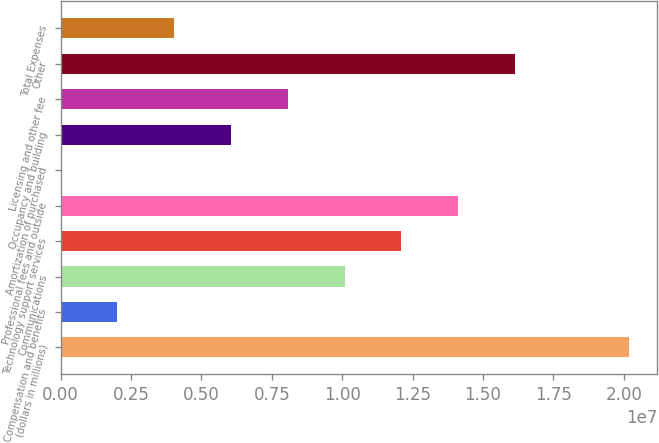Convert chart. <chart><loc_0><loc_0><loc_500><loc_500><bar_chart><fcel>(dollars in millions)<fcel>Compensation and benefits<fcel>Communications<fcel>Technology support services<fcel>Professional fees and outside<fcel>Amortization of purchased<fcel>Occupancy and building<fcel>Licensing and other fee<fcel>Other<fcel>Total Expenses<nl><fcel>2.0172e+07<fcel>2.0172e+06<fcel>1.0086e+07<fcel>1.21032e+07<fcel>1.41204e+07<fcel>1<fcel>6.05161e+06<fcel>8.06881e+06<fcel>1.61376e+07<fcel>4.0344e+06<nl></chart> 